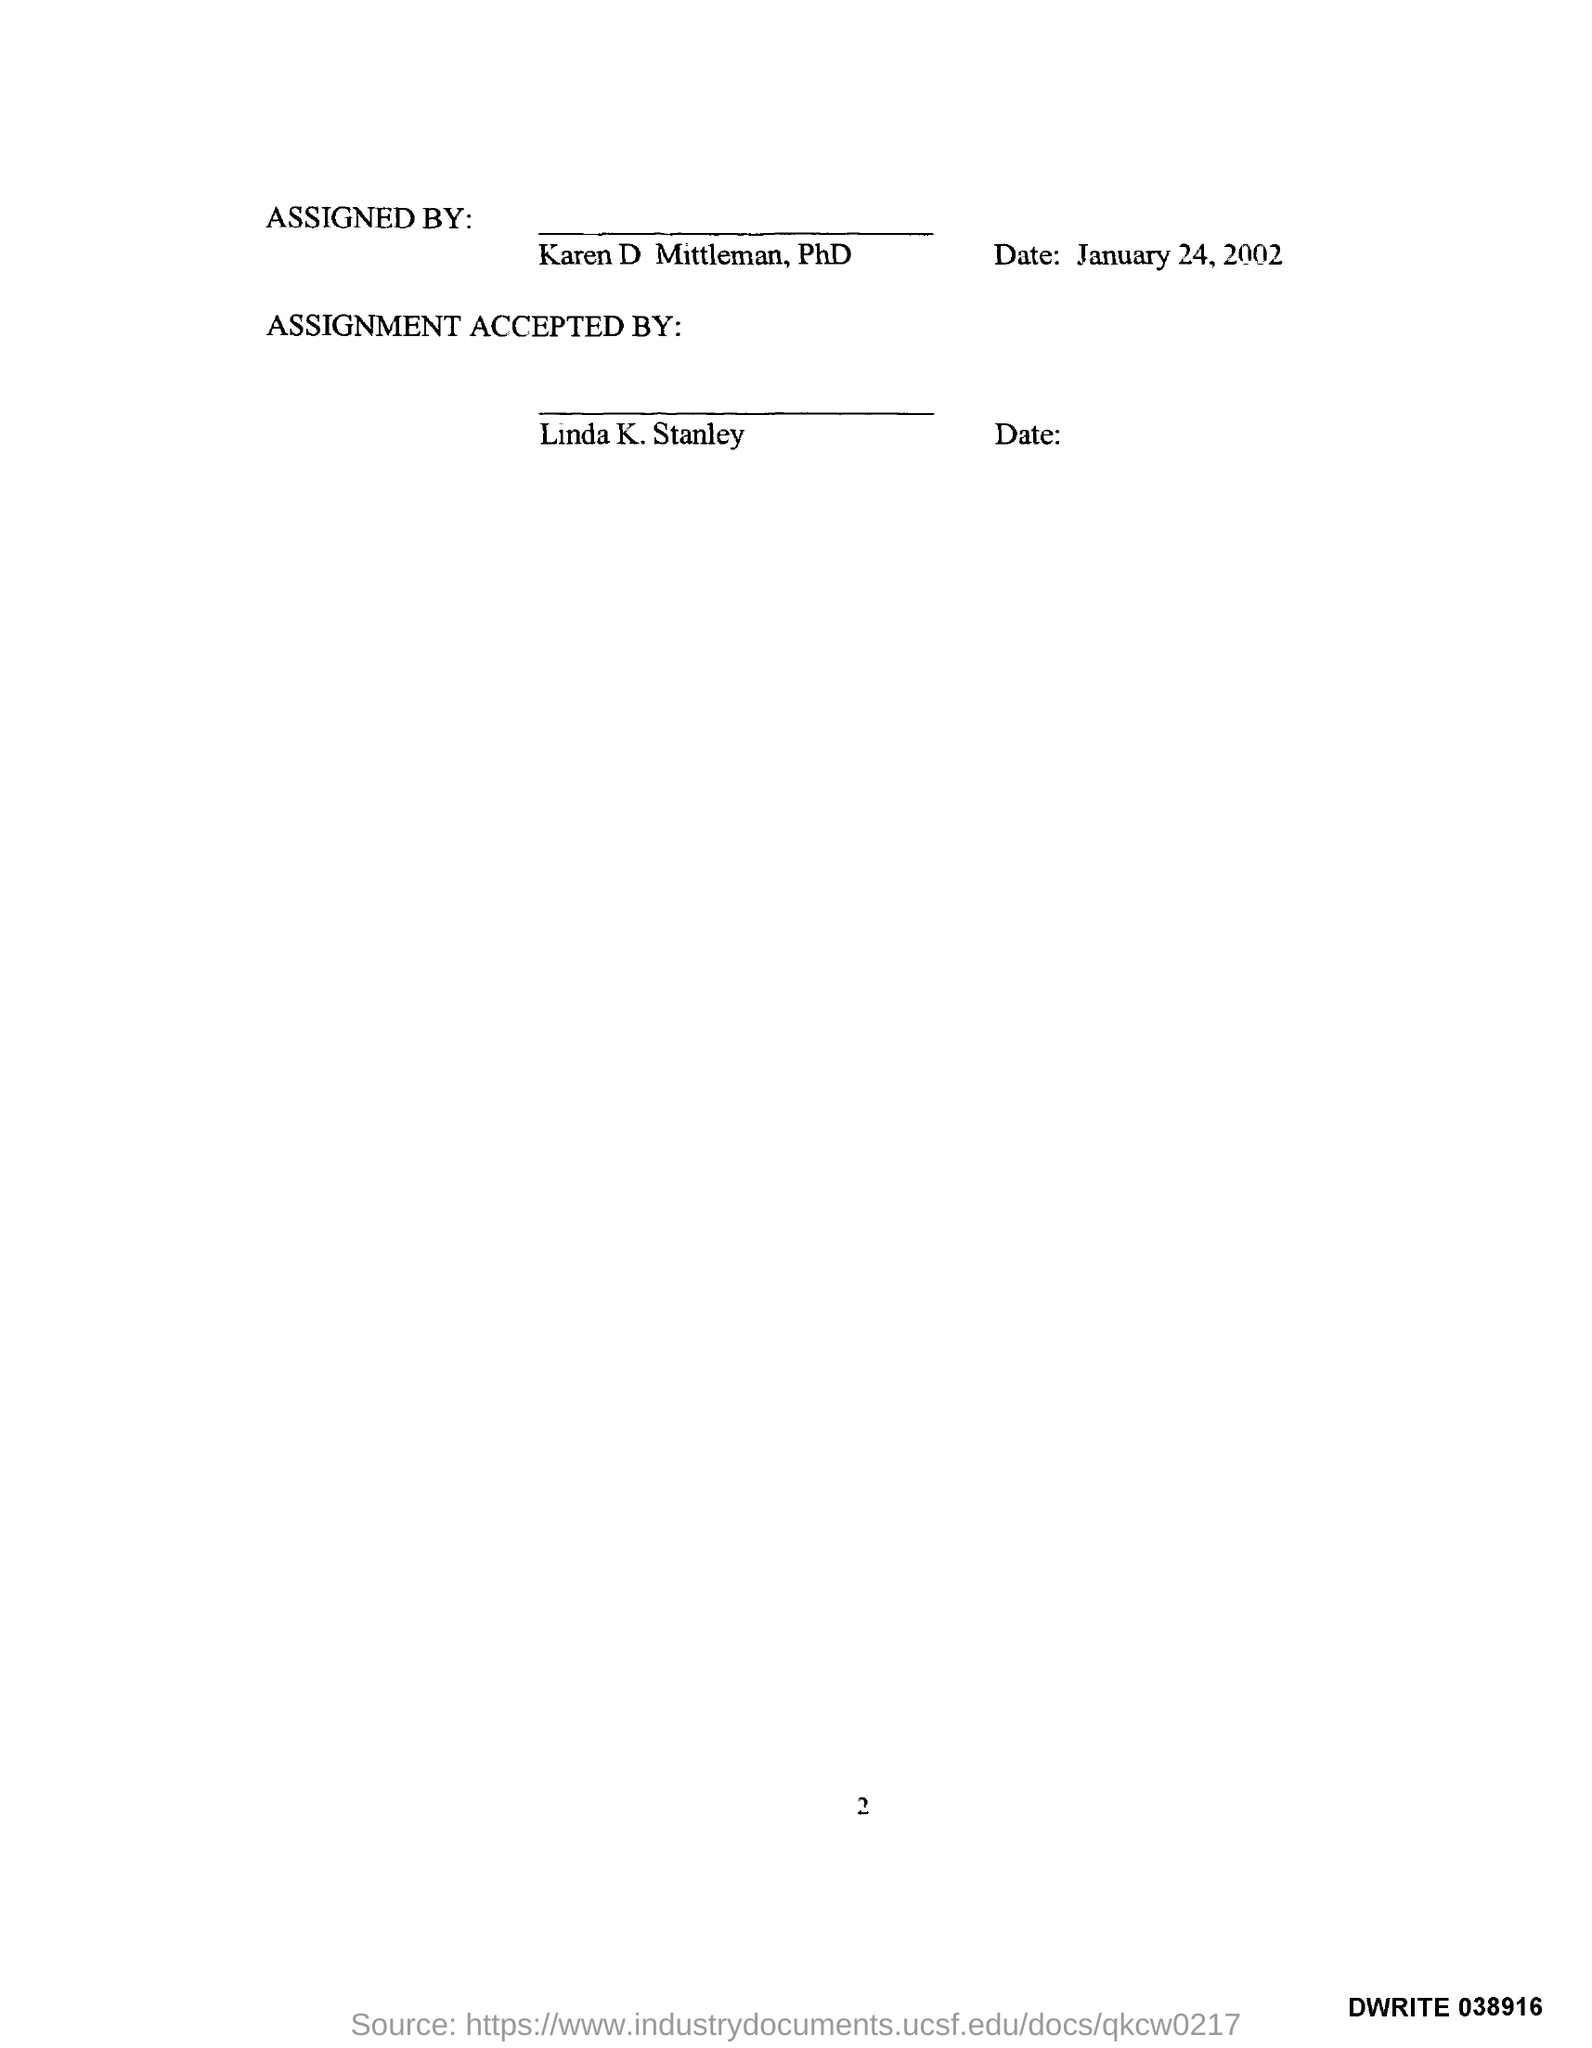What is the page no mentioned in this document?
 2 